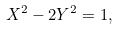Convert formula to latex. <formula><loc_0><loc_0><loc_500><loc_500>X ^ { 2 } - 2 Y ^ { 2 } = 1 ,</formula> 